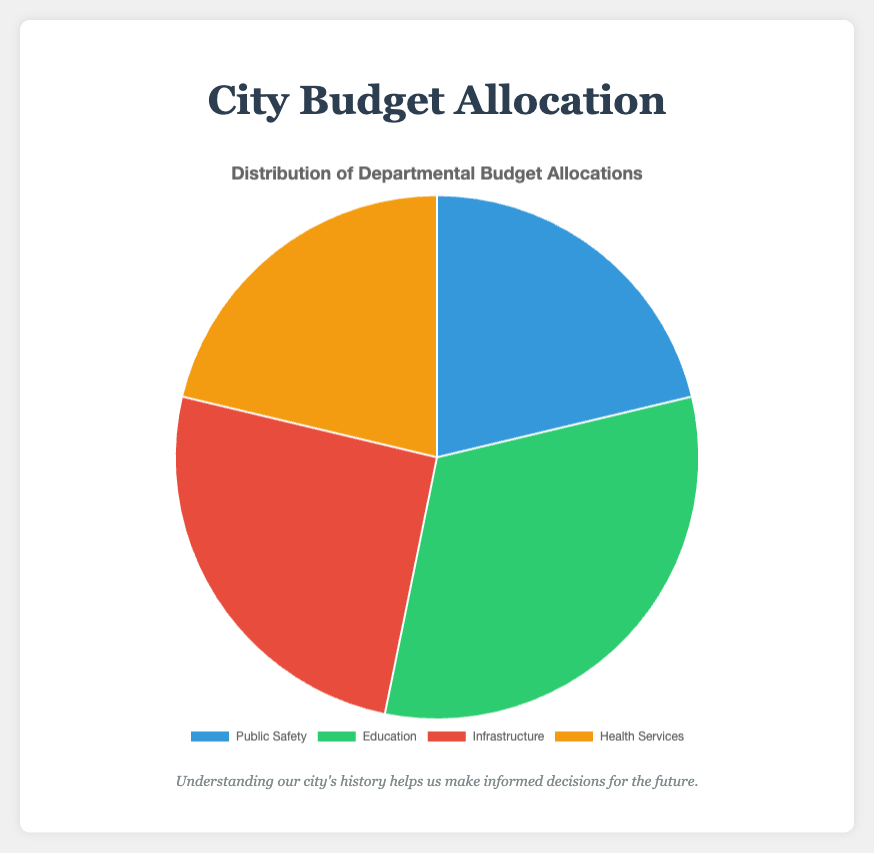What is the total budget allocation for Education? The pie chart shows the departmental budget allocations. By summing the individual allocations for Primary Schools ($2,000,000), Secondary Schools ($3,000,000), and Higher Education ($2,500,000), we get a total of $7,500,000 for Education
Answer: $7,500,000 Which department has the highest budget allocation? From the pie chart, Education has the highest budget allocation with a total of $7,500,000, compared to other departments' allocations
Answer: Education How much more is allocated to Infrastructure compared to Public Safety? According to the pie chart, the budget for Infrastructure is $6,000,000 while for Public Safety it’s $5,000,000. The difference is $6,000,000 - $5,000,000
Answer: $1,000,000 What is the average budget allocation per department? By summing the total budgets for all four departments (Public Safety: $5,000,000, Education: $7,500,000, Infrastructure: $6,000,000, Health Services: $5,000,000), the total is $23,500,000. Dividing by 4 departments gives $23,500,000 / 4
Answer: $5,875,000 Which category has the smallest budget allocation, and what is its amount? The pie chart shows that Health Services has the smallest budget allocation equal to $5,000,000
Answer: Health Services, $5,000,000 How does the budget allocation for Public Safety compare to that for Health Services visually and numerically? Both Public Safety and Health Services have an equal budget allocation of $5,000,000, as indicated by equally-sized sectors in the pie chart
Answer: Equal, $5,000,000 What percentage of the total budget is allocated to Infrastructure? The total budget is $23,500,000. The budget for Infrastructure is $6,000,000. The percentage is calculated as ($6,000,000 / $23,500,000) * 100 ≈ 25.53%
Answer: Approximately 25.53% Which budget allocation category has a green-colored section in the pie chart, and how much is the allocation for that category? The section of the pie chart colored green represents Education, which has a budget allocation of $7,500,000
Answer: Education, $7,500,000 What is the cumulative budget allocations of the categories besides Education? Summing the budget allocations of Public Safety ($5,000,000), Infrastructure ($6,000,000), and Health Services ($5,000,000), the total is $16,000,000
Answer: $16,000,000 